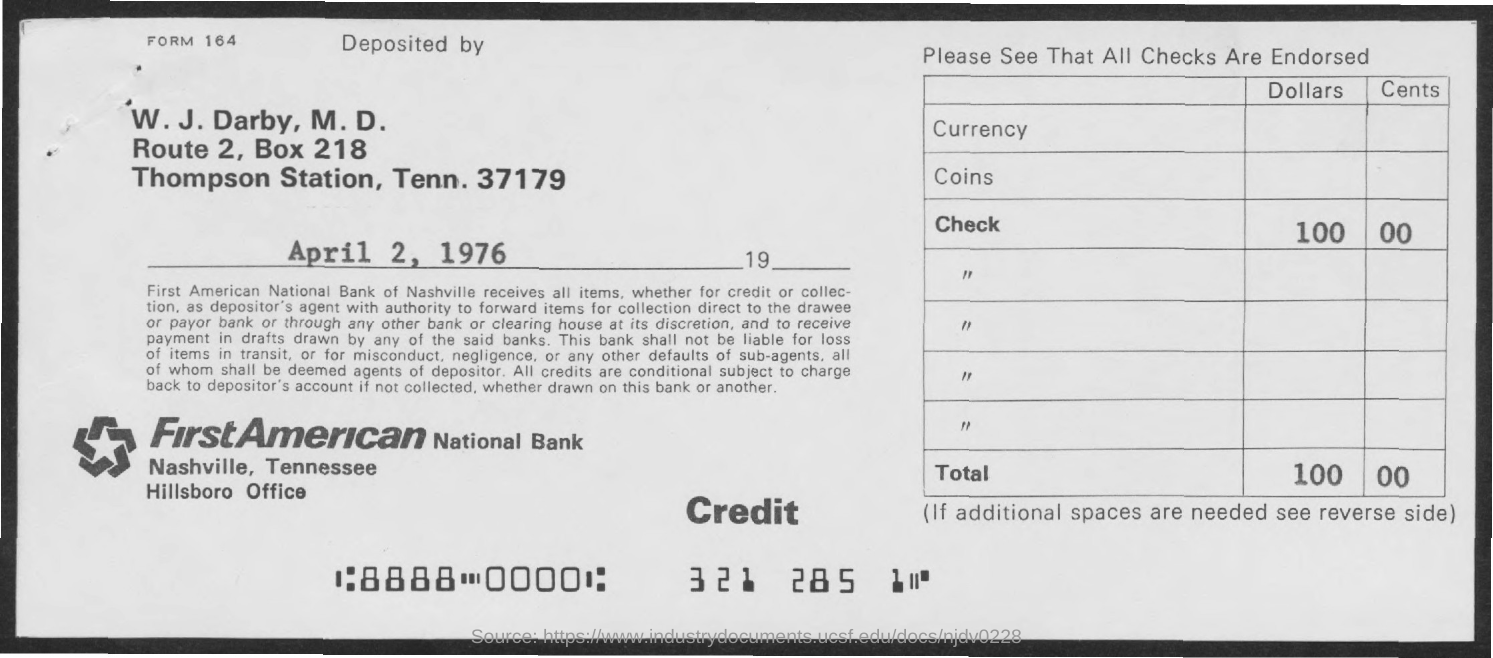Point out several critical features in this image. The memorandum is dated April 2, 1976. The BOX number is 218. First American National Bank is the name of a bank. 